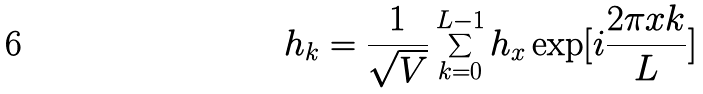<formula> <loc_0><loc_0><loc_500><loc_500>h _ { k } = \frac { 1 } { \sqrt { V } } \sum _ { k = 0 } ^ { L - 1 } h _ { x } \exp [ i \frac { 2 \pi x k } { L } ] \</formula> 